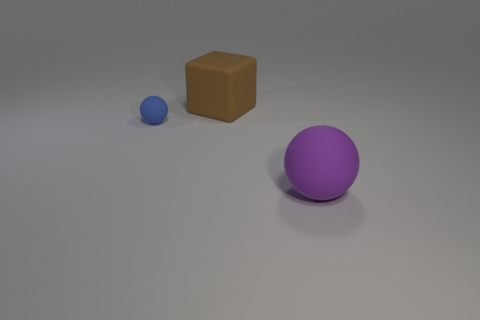The thing that is in front of the large brown matte block and right of the tiny sphere is what color?
Make the answer very short. Purple. Are there any other things that are the same size as the brown matte thing?
Offer a very short reply. Yes. Are there more brown matte cubes that are on the right side of the blue thing than big brown matte things right of the block?
Offer a terse response. Yes. Is the size of the rubber ball to the right of the rubber cube the same as the large brown cube?
Provide a short and direct response. Yes. There is a brown matte cube that is to the left of the big rubber thing in front of the large rubber block; how many blue rubber objects are left of it?
Ensure brevity in your answer.  1. There is a matte thing that is both in front of the brown matte thing and behind the big purple matte object; how big is it?
Provide a short and direct response. Small. How many other things are the same shape as the blue thing?
Provide a short and direct response. 1. There is a large brown cube; what number of purple matte objects are in front of it?
Offer a very short reply. 1. Are there fewer big brown blocks right of the big matte block than big balls left of the blue rubber thing?
Your answer should be compact. No. The large matte thing in front of the large thing that is behind the sphere that is in front of the blue thing is what shape?
Your response must be concise. Sphere. 